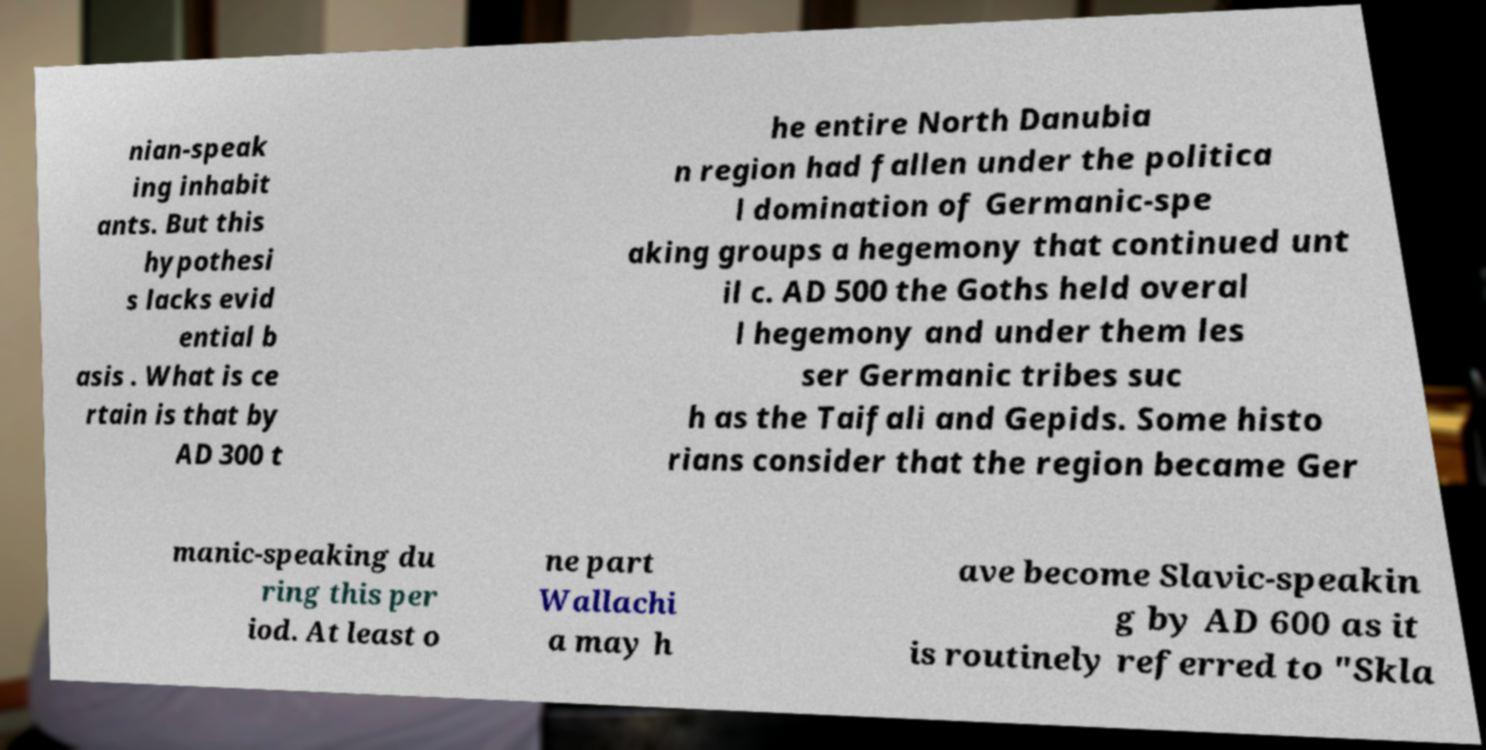Can you accurately transcribe the text from the provided image for me? nian-speak ing inhabit ants. But this hypothesi s lacks evid ential b asis . What is ce rtain is that by AD 300 t he entire North Danubia n region had fallen under the politica l domination of Germanic-spe aking groups a hegemony that continued unt il c. AD 500 the Goths held overal l hegemony and under them les ser Germanic tribes suc h as the Taifali and Gepids. Some histo rians consider that the region became Ger manic-speaking du ring this per iod. At least o ne part Wallachi a may h ave become Slavic-speakin g by AD 600 as it is routinely referred to "Skla 